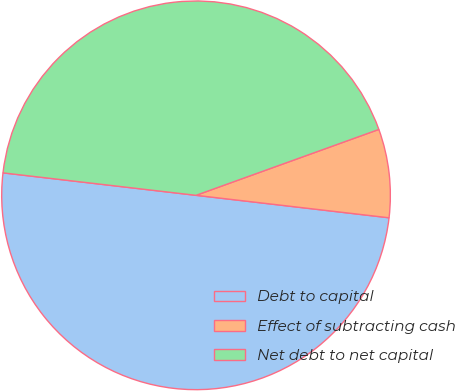Convert chart to OTSL. <chart><loc_0><loc_0><loc_500><loc_500><pie_chart><fcel>Debt to capital<fcel>Effect of subtracting cash<fcel>Net debt to net capital<nl><fcel>50.0%<fcel>7.35%<fcel>42.65%<nl></chart> 